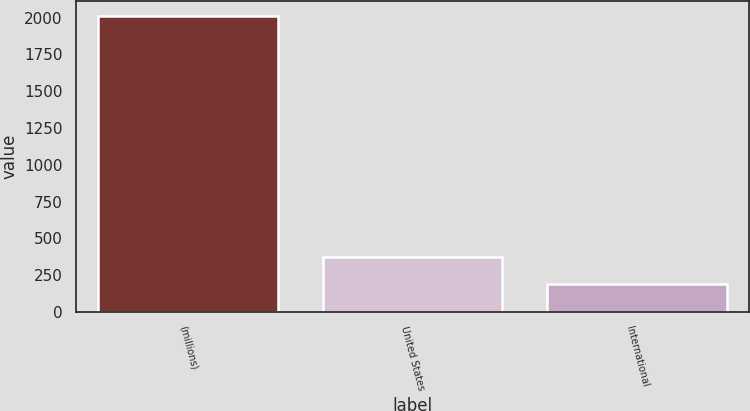Convert chart to OTSL. <chart><loc_0><loc_0><loc_500><loc_500><bar_chart><fcel>(millions)<fcel>United States<fcel>International<nl><fcel>2015<fcel>370.61<fcel>187.9<nl></chart> 